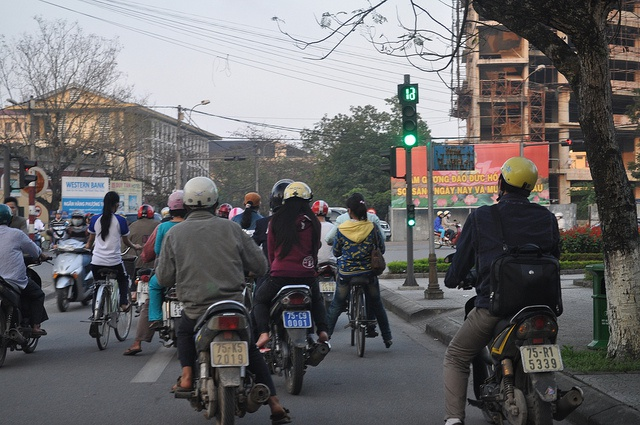Describe the objects in this image and their specific colors. I can see people in lightgray, black, gray, and olive tones, people in lightgray, gray, black, and darkgray tones, motorcycle in lightgray, black, gray, and darkgray tones, motorcycle in lightgray, black, gray, and maroon tones, and people in lightgray, black, purple, gray, and darkgray tones in this image. 